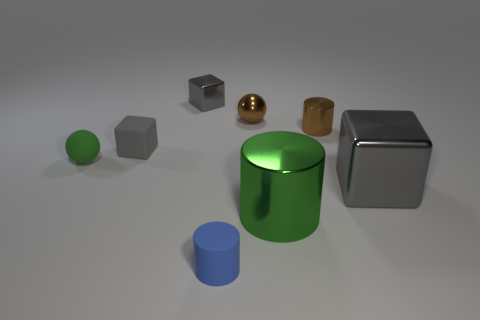Is there any indication of the size of these objects? The image doesn't provide direct indicators of size or scale. However, they are depicted with shadows and reflections that give an impression of their relative sizes to one another. The absence of familiar objects or a background context makes it challenging to accurately determine their absolute sizes. 